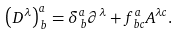Convert formula to latex. <formula><loc_0><loc_0><loc_500><loc_500>\left ( D ^ { \lambda } \right ) _ { \, b } ^ { a } = \delta _ { \, b } ^ { a } \partial ^ { \lambda } + f _ { \, b c } ^ { a } A ^ { \lambda c } .</formula> 